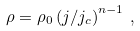Convert formula to latex. <formula><loc_0><loc_0><loc_500><loc_500>\rho = \rho _ { 0 } \left ( j / j _ { c } \right ) ^ { n - 1 } \, ,</formula> 